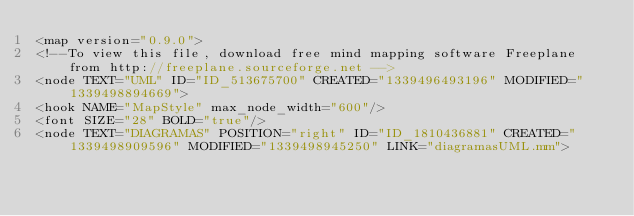Convert code to text. <code><loc_0><loc_0><loc_500><loc_500><_ObjectiveC_><map version="0.9.0">
<!--To view this file, download free mind mapping software Freeplane from http://freeplane.sourceforge.net -->
<node TEXT="UML" ID="ID_513675700" CREATED="1339496493196" MODIFIED="1339498894669">
<hook NAME="MapStyle" max_node_width="600"/>
<font SIZE="28" BOLD="true"/>
<node TEXT="DIAGRAMAS" POSITION="right" ID="ID_1810436881" CREATED="1339498909596" MODIFIED="1339498945250" LINK="diagramasUML.mm"></code> 